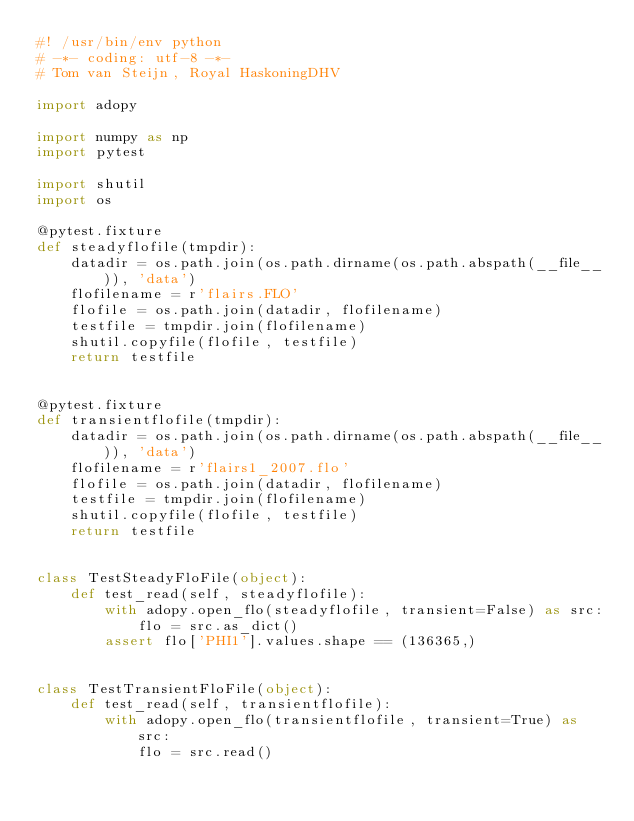<code> <loc_0><loc_0><loc_500><loc_500><_Python_>#! /usr/bin/env python
# -*- coding: utf-8 -*-
# Tom van Steijn, Royal HaskoningDHV

import adopy

import numpy as np
import pytest

import shutil
import os

@pytest.fixture
def steadyflofile(tmpdir):
    datadir = os.path.join(os.path.dirname(os.path.abspath(__file__)), 'data')
    flofilename = r'flairs.FLO'
    flofile = os.path.join(datadir, flofilename)
    testfile = tmpdir.join(flofilename)
    shutil.copyfile(flofile, testfile)
    return testfile


@pytest.fixture
def transientflofile(tmpdir):
    datadir = os.path.join(os.path.dirname(os.path.abspath(__file__)), 'data')
    flofilename = r'flairs1_2007.flo'
    flofile = os.path.join(datadir, flofilename)
    testfile = tmpdir.join(flofilename)
    shutil.copyfile(flofile, testfile)
    return testfile


class TestSteadyFloFile(object):
    def test_read(self, steadyflofile):
        with adopy.open_flo(steadyflofile, transient=False) as src:
            flo = src.as_dict()
        assert flo['PHI1'].values.shape == (136365,)


class TestTransientFloFile(object):
    def test_read(self, transientflofile):
        with adopy.open_flo(transientflofile, transient=True) as src:
            flo = src.read()</code> 